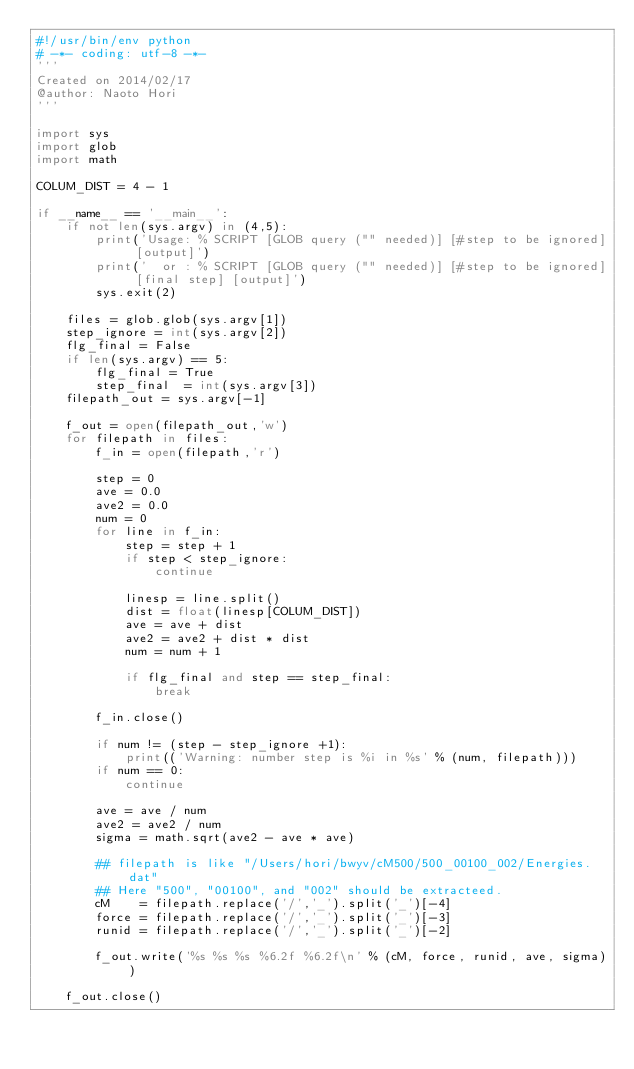Convert code to text. <code><loc_0><loc_0><loc_500><loc_500><_Python_>#!/usr/bin/env python
# -*- coding: utf-8 -*-
'''
Created on 2014/02/17
@author: Naoto Hori
'''

import sys
import glob
import math

COLUM_DIST = 4 - 1

if __name__ == '__main__':
    if not len(sys.argv) in (4,5):
        print('Usage: % SCRIPT [GLOB query ("" needed)] [#step to be ignored] [output]')
        print('  or : % SCRIPT [GLOB query ("" needed)] [#step to be ignored] [final step] [output]')
        sys.exit(2)

    files = glob.glob(sys.argv[1])
    step_ignore = int(sys.argv[2])
    flg_final = False
    if len(sys.argv) == 5:
        flg_final = True
        step_final  = int(sys.argv[3])
    filepath_out = sys.argv[-1]

    f_out = open(filepath_out,'w')
    for filepath in files:
        f_in = open(filepath,'r')

        step = 0
        ave = 0.0
        ave2 = 0.0
        num = 0
        for line in f_in:
            step = step + 1
            if step < step_ignore:
                continue 

            linesp = line.split()
            dist = float(linesp[COLUM_DIST])
            ave = ave + dist
            ave2 = ave2 + dist * dist
            num = num + 1

            if flg_final and step == step_final:
                break

        f_in.close()

        if num != (step - step_ignore +1):
            print(('Warning: number step is %i in %s' % (num, filepath)))
        if num == 0:
            continue
            
        ave = ave / num
        ave2 = ave2 / num
        sigma = math.sqrt(ave2 - ave * ave)

        ## filepath is like "/Users/hori/bwyv/cM500/500_00100_002/Energies.dat"
        ## Here "500", "00100", and "002" should be extracteed.
        cM    = filepath.replace('/','_').split('_')[-4]
        force = filepath.replace('/','_').split('_')[-3]
        runid = filepath.replace('/','_').split('_')[-2]

        f_out.write('%s %s %s %6.2f %6.2f\n' % (cM, force, runid, ave, sigma))

    f_out.close()


</code> 